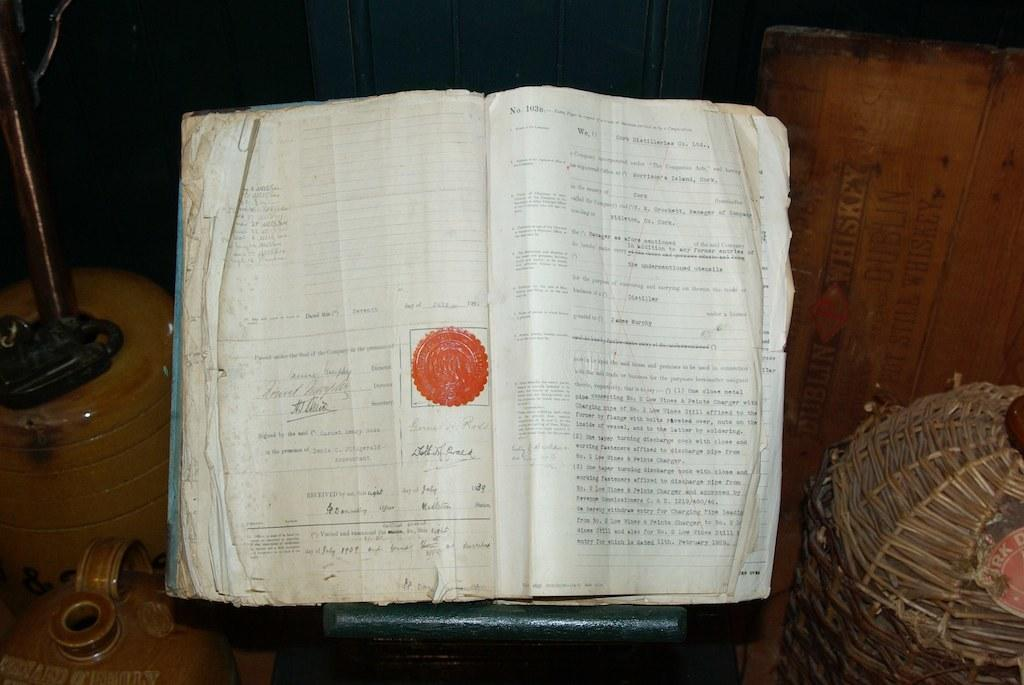What is the main object in the image? There is a book in the image. What can be found on the pages of the book? The pages of the book have text printed on them. What else is present in the image besides the book? There are objects in the image. Where is the container located in the image? The container is at the right side of the image. What type of crime is being committed in the image? There is no crime being committed in the image; it features a book with text on its pages and other unspecified objects. How many roses are visible in the image? There are no roses present in the image. 